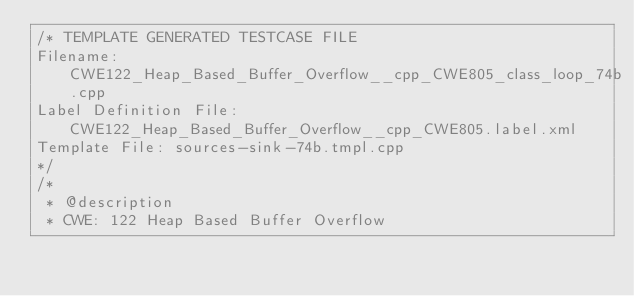<code> <loc_0><loc_0><loc_500><loc_500><_C++_>/* TEMPLATE GENERATED TESTCASE FILE
Filename: CWE122_Heap_Based_Buffer_Overflow__cpp_CWE805_class_loop_74b.cpp
Label Definition File: CWE122_Heap_Based_Buffer_Overflow__cpp_CWE805.label.xml
Template File: sources-sink-74b.tmpl.cpp
*/
/*
 * @description
 * CWE: 122 Heap Based Buffer Overflow</code> 